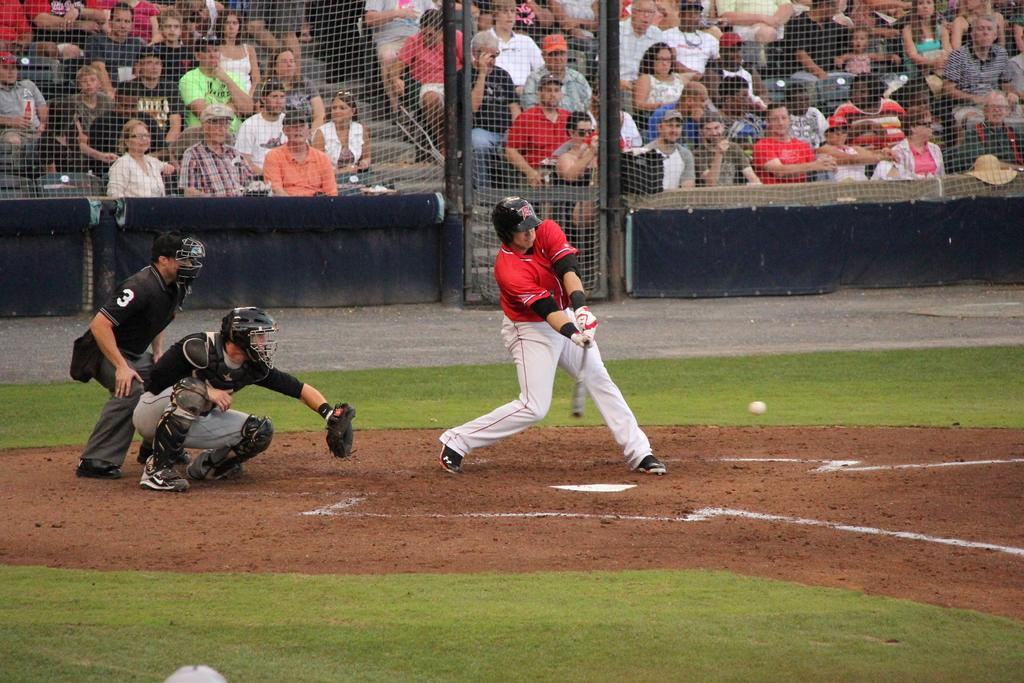<image>
Write a terse but informative summary of the picture. The umpire behind the catcher has the number 3 on his sleeve. 